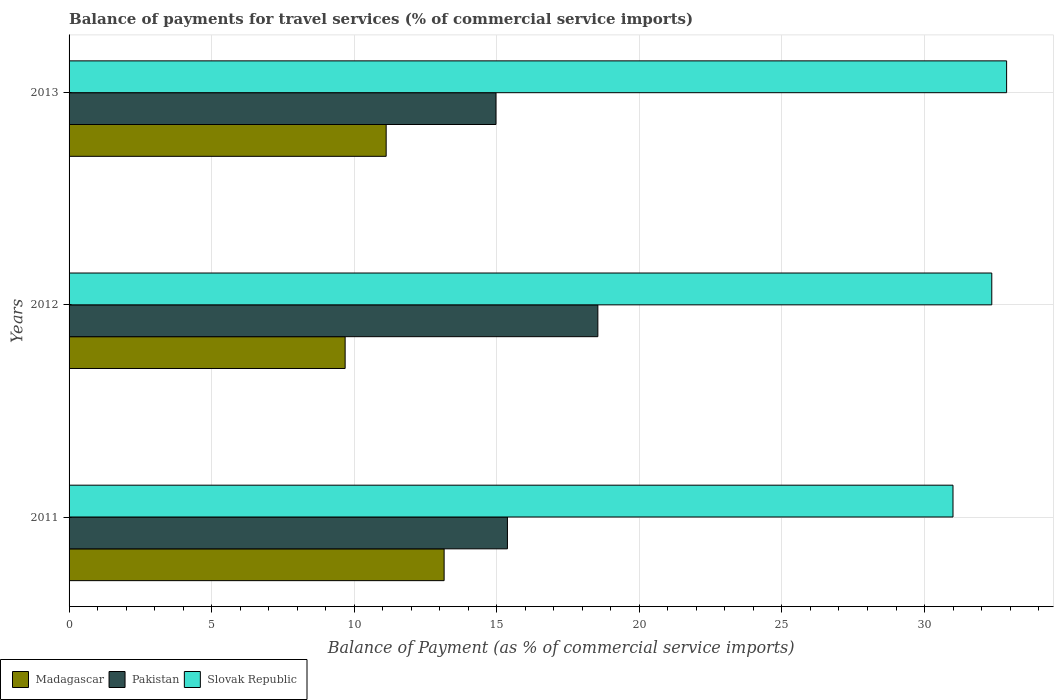Are the number of bars per tick equal to the number of legend labels?
Offer a terse response. Yes. Are the number of bars on each tick of the Y-axis equal?
Offer a very short reply. Yes. How many bars are there on the 2nd tick from the bottom?
Make the answer very short. 3. What is the label of the 2nd group of bars from the top?
Offer a terse response. 2012. In how many cases, is the number of bars for a given year not equal to the number of legend labels?
Give a very brief answer. 0. What is the balance of payments for travel services in Pakistan in 2013?
Your answer should be very brief. 14.97. Across all years, what is the maximum balance of payments for travel services in Madagascar?
Keep it short and to the point. 13.15. Across all years, what is the minimum balance of payments for travel services in Slovak Republic?
Give a very brief answer. 31. What is the total balance of payments for travel services in Pakistan in the graph?
Offer a terse response. 48.89. What is the difference between the balance of payments for travel services in Slovak Republic in 2011 and that in 2012?
Your answer should be very brief. -1.36. What is the difference between the balance of payments for travel services in Pakistan in 2011 and the balance of payments for travel services in Madagascar in 2012?
Offer a terse response. 5.69. What is the average balance of payments for travel services in Madagascar per year?
Provide a succinct answer. 11.32. In the year 2013, what is the difference between the balance of payments for travel services in Madagascar and balance of payments for travel services in Slovak Republic?
Offer a very short reply. -21.76. What is the ratio of the balance of payments for travel services in Slovak Republic in 2011 to that in 2013?
Give a very brief answer. 0.94. What is the difference between the highest and the second highest balance of payments for travel services in Madagascar?
Give a very brief answer. 2.03. What is the difference between the highest and the lowest balance of payments for travel services in Pakistan?
Make the answer very short. 3.57. Is the sum of the balance of payments for travel services in Madagascar in 2011 and 2012 greater than the maximum balance of payments for travel services in Slovak Republic across all years?
Offer a very short reply. No. What does the 3rd bar from the bottom in 2011 represents?
Your response must be concise. Slovak Republic. How many bars are there?
Give a very brief answer. 9. Are all the bars in the graph horizontal?
Your answer should be compact. Yes. How many years are there in the graph?
Keep it short and to the point. 3. Are the values on the major ticks of X-axis written in scientific E-notation?
Ensure brevity in your answer.  No. Does the graph contain any zero values?
Make the answer very short. No. Where does the legend appear in the graph?
Keep it short and to the point. Bottom left. How many legend labels are there?
Ensure brevity in your answer.  3. How are the legend labels stacked?
Keep it short and to the point. Horizontal. What is the title of the graph?
Your answer should be very brief. Balance of payments for travel services (% of commercial service imports). What is the label or title of the X-axis?
Offer a terse response. Balance of Payment (as % of commercial service imports). What is the Balance of Payment (as % of commercial service imports) of Madagascar in 2011?
Provide a succinct answer. 13.15. What is the Balance of Payment (as % of commercial service imports) in Pakistan in 2011?
Ensure brevity in your answer.  15.37. What is the Balance of Payment (as % of commercial service imports) in Slovak Republic in 2011?
Make the answer very short. 31. What is the Balance of Payment (as % of commercial service imports) of Madagascar in 2012?
Your response must be concise. 9.68. What is the Balance of Payment (as % of commercial service imports) in Pakistan in 2012?
Give a very brief answer. 18.54. What is the Balance of Payment (as % of commercial service imports) in Slovak Republic in 2012?
Provide a succinct answer. 32.36. What is the Balance of Payment (as % of commercial service imports) in Madagascar in 2013?
Ensure brevity in your answer.  11.12. What is the Balance of Payment (as % of commercial service imports) of Pakistan in 2013?
Offer a very short reply. 14.97. What is the Balance of Payment (as % of commercial service imports) of Slovak Republic in 2013?
Make the answer very short. 32.88. Across all years, what is the maximum Balance of Payment (as % of commercial service imports) of Madagascar?
Your answer should be compact. 13.15. Across all years, what is the maximum Balance of Payment (as % of commercial service imports) of Pakistan?
Make the answer very short. 18.54. Across all years, what is the maximum Balance of Payment (as % of commercial service imports) of Slovak Republic?
Ensure brevity in your answer.  32.88. Across all years, what is the minimum Balance of Payment (as % of commercial service imports) in Madagascar?
Give a very brief answer. 9.68. Across all years, what is the minimum Balance of Payment (as % of commercial service imports) in Pakistan?
Ensure brevity in your answer.  14.97. Across all years, what is the minimum Balance of Payment (as % of commercial service imports) of Slovak Republic?
Provide a succinct answer. 31. What is the total Balance of Payment (as % of commercial service imports) of Madagascar in the graph?
Provide a short and direct response. 33.95. What is the total Balance of Payment (as % of commercial service imports) of Pakistan in the graph?
Your answer should be compact. 48.89. What is the total Balance of Payment (as % of commercial service imports) of Slovak Republic in the graph?
Keep it short and to the point. 96.23. What is the difference between the Balance of Payment (as % of commercial service imports) in Madagascar in 2011 and that in 2012?
Provide a succinct answer. 3.47. What is the difference between the Balance of Payment (as % of commercial service imports) in Pakistan in 2011 and that in 2012?
Give a very brief answer. -3.17. What is the difference between the Balance of Payment (as % of commercial service imports) of Slovak Republic in 2011 and that in 2012?
Offer a very short reply. -1.36. What is the difference between the Balance of Payment (as % of commercial service imports) in Madagascar in 2011 and that in 2013?
Offer a very short reply. 2.03. What is the difference between the Balance of Payment (as % of commercial service imports) of Pakistan in 2011 and that in 2013?
Your response must be concise. 0.4. What is the difference between the Balance of Payment (as % of commercial service imports) in Slovak Republic in 2011 and that in 2013?
Keep it short and to the point. -1.88. What is the difference between the Balance of Payment (as % of commercial service imports) of Madagascar in 2012 and that in 2013?
Provide a succinct answer. -1.44. What is the difference between the Balance of Payment (as % of commercial service imports) in Pakistan in 2012 and that in 2013?
Your answer should be very brief. 3.57. What is the difference between the Balance of Payment (as % of commercial service imports) of Slovak Republic in 2012 and that in 2013?
Your answer should be compact. -0.52. What is the difference between the Balance of Payment (as % of commercial service imports) in Madagascar in 2011 and the Balance of Payment (as % of commercial service imports) in Pakistan in 2012?
Offer a very short reply. -5.39. What is the difference between the Balance of Payment (as % of commercial service imports) in Madagascar in 2011 and the Balance of Payment (as % of commercial service imports) in Slovak Republic in 2012?
Provide a short and direct response. -19.21. What is the difference between the Balance of Payment (as % of commercial service imports) in Pakistan in 2011 and the Balance of Payment (as % of commercial service imports) in Slovak Republic in 2012?
Make the answer very short. -16.99. What is the difference between the Balance of Payment (as % of commercial service imports) of Madagascar in 2011 and the Balance of Payment (as % of commercial service imports) of Pakistan in 2013?
Keep it short and to the point. -1.82. What is the difference between the Balance of Payment (as % of commercial service imports) of Madagascar in 2011 and the Balance of Payment (as % of commercial service imports) of Slovak Republic in 2013?
Provide a short and direct response. -19.73. What is the difference between the Balance of Payment (as % of commercial service imports) of Pakistan in 2011 and the Balance of Payment (as % of commercial service imports) of Slovak Republic in 2013?
Provide a succinct answer. -17.51. What is the difference between the Balance of Payment (as % of commercial service imports) of Madagascar in 2012 and the Balance of Payment (as % of commercial service imports) of Pakistan in 2013?
Offer a very short reply. -5.29. What is the difference between the Balance of Payment (as % of commercial service imports) of Madagascar in 2012 and the Balance of Payment (as % of commercial service imports) of Slovak Republic in 2013?
Your response must be concise. -23.2. What is the difference between the Balance of Payment (as % of commercial service imports) of Pakistan in 2012 and the Balance of Payment (as % of commercial service imports) of Slovak Republic in 2013?
Offer a very short reply. -14.33. What is the average Balance of Payment (as % of commercial service imports) of Madagascar per year?
Provide a short and direct response. 11.32. What is the average Balance of Payment (as % of commercial service imports) of Pakistan per year?
Your response must be concise. 16.3. What is the average Balance of Payment (as % of commercial service imports) of Slovak Republic per year?
Offer a very short reply. 32.08. In the year 2011, what is the difference between the Balance of Payment (as % of commercial service imports) of Madagascar and Balance of Payment (as % of commercial service imports) of Pakistan?
Make the answer very short. -2.22. In the year 2011, what is the difference between the Balance of Payment (as % of commercial service imports) in Madagascar and Balance of Payment (as % of commercial service imports) in Slovak Republic?
Offer a terse response. -17.85. In the year 2011, what is the difference between the Balance of Payment (as % of commercial service imports) of Pakistan and Balance of Payment (as % of commercial service imports) of Slovak Republic?
Offer a terse response. -15.62. In the year 2012, what is the difference between the Balance of Payment (as % of commercial service imports) in Madagascar and Balance of Payment (as % of commercial service imports) in Pakistan?
Keep it short and to the point. -8.86. In the year 2012, what is the difference between the Balance of Payment (as % of commercial service imports) of Madagascar and Balance of Payment (as % of commercial service imports) of Slovak Republic?
Give a very brief answer. -22.68. In the year 2012, what is the difference between the Balance of Payment (as % of commercial service imports) of Pakistan and Balance of Payment (as % of commercial service imports) of Slovak Republic?
Give a very brief answer. -13.81. In the year 2013, what is the difference between the Balance of Payment (as % of commercial service imports) of Madagascar and Balance of Payment (as % of commercial service imports) of Pakistan?
Your answer should be compact. -3.85. In the year 2013, what is the difference between the Balance of Payment (as % of commercial service imports) in Madagascar and Balance of Payment (as % of commercial service imports) in Slovak Republic?
Give a very brief answer. -21.76. In the year 2013, what is the difference between the Balance of Payment (as % of commercial service imports) in Pakistan and Balance of Payment (as % of commercial service imports) in Slovak Republic?
Keep it short and to the point. -17.91. What is the ratio of the Balance of Payment (as % of commercial service imports) in Madagascar in 2011 to that in 2012?
Ensure brevity in your answer.  1.36. What is the ratio of the Balance of Payment (as % of commercial service imports) in Pakistan in 2011 to that in 2012?
Your answer should be compact. 0.83. What is the ratio of the Balance of Payment (as % of commercial service imports) of Slovak Republic in 2011 to that in 2012?
Make the answer very short. 0.96. What is the ratio of the Balance of Payment (as % of commercial service imports) of Madagascar in 2011 to that in 2013?
Your response must be concise. 1.18. What is the ratio of the Balance of Payment (as % of commercial service imports) of Pakistan in 2011 to that in 2013?
Provide a succinct answer. 1.03. What is the ratio of the Balance of Payment (as % of commercial service imports) of Slovak Republic in 2011 to that in 2013?
Offer a very short reply. 0.94. What is the ratio of the Balance of Payment (as % of commercial service imports) in Madagascar in 2012 to that in 2013?
Offer a very short reply. 0.87. What is the ratio of the Balance of Payment (as % of commercial service imports) of Pakistan in 2012 to that in 2013?
Provide a short and direct response. 1.24. What is the ratio of the Balance of Payment (as % of commercial service imports) of Slovak Republic in 2012 to that in 2013?
Give a very brief answer. 0.98. What is the difference between the highest and the second highest Balance of Payment (as % of commercial service imports) of Madagascar?
Your answer should be very brief. 2.03. What is the difference between the highest and the second highest Balance of Payment (as % of commercial service imports) of Pakistan?
Your answer should be very brief. 3.17. What is the difference between the highest and the second highest Balance of Payment (as % of commercial service imports) of Slovak Republic?
Your answer should be very brief. 0.52. What is the difference between the highest and the lowest Balance of Payment (as % of commercial service imports) of Madagascar?
Make the answer very short. 3.47. What is the difference between the highest and the lowest Balance of Payment (as % of commercial service imports) of Pakistan?
Your response must be concise. 3.57. What is the difference between the highest and the lowest Balance of Payment (as % of commercial service imports) in Slovak Republic?
Offer a terse response. 1.88. 